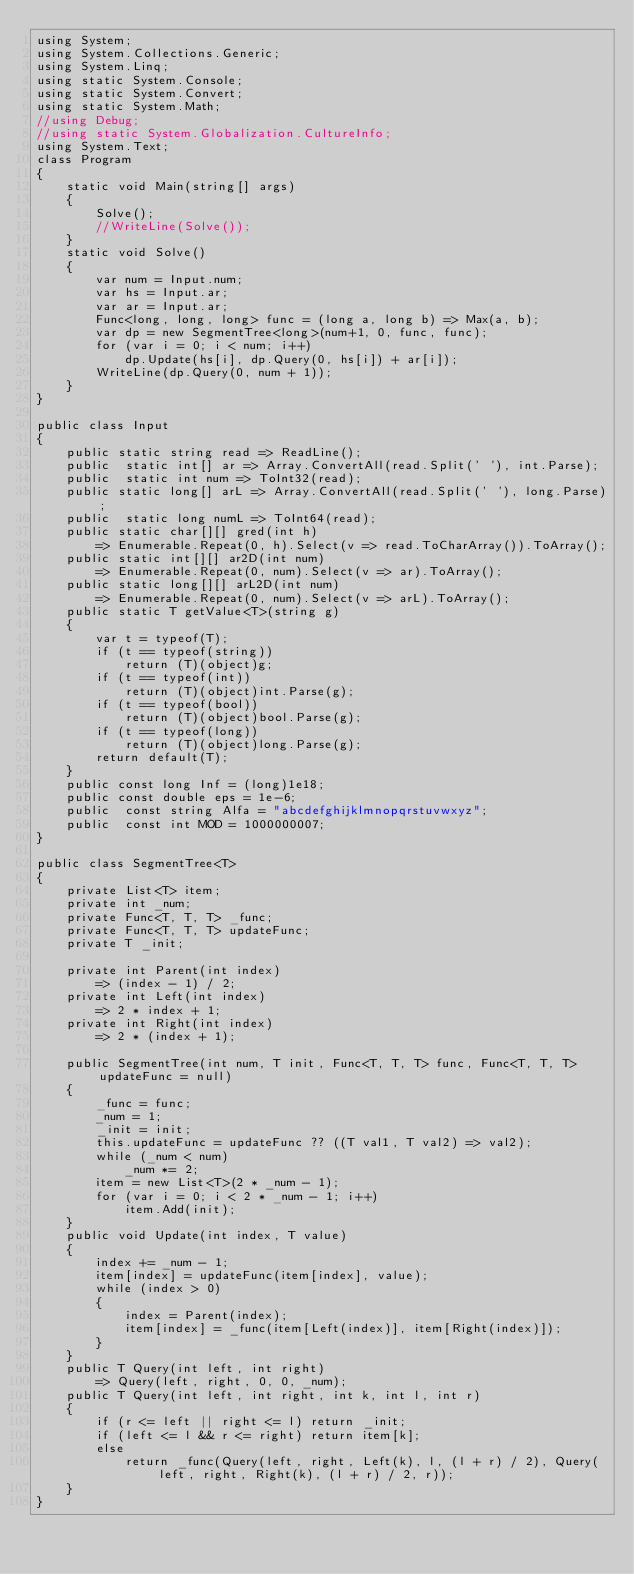Convert code to text. <code><loc_0><loc_0><loc_500><loc_500><_C#_>using System;
using System.Collections.Generic;
using System.Linq;
using static System.Console;
using static System.Convert;
using static System.Math;
//using Debug;
//using static System.Globalization.CultureInfo;
using System.Text;
class Program
{
    static void Main(string[] args)
    {
        Solve();
        //WriteLine(Solve());
    }
    static void Solve()
    {
        var num = Input.num;
        var hs = Input.ar;
        var ar = Input.ar;
        Func<long, long, long> func = (long a, long b) => Max(a, b);
        var dp = new SegmentTree<long>(num+1, 0, func, func);
        for (var i = 0; i < num; i++)
            dp.Update(hs[i], dp.Query(0, hs[i]) + ar[i]);
        WriteLine(dp.Query(0, num + 1));
    }
}

public class Input
{
    public static string read => ReadLine();
    public  static int[] ar => Array.ConvertAll(read.Split(' '), int.Parse);
    public  static int num => ToInt32(read);
    public static long[] arL => Array.ConvertAll(read.Split(' '), long.Parse);
    public  static long numL => ToInt64(read);
    public static char[][] gred(int h) 
        => Enumerable.Repeat(0, h).Select(v => read.ToCharArray()).ToArray();
    public static int[][] ar2D(int num)
        => Enumerable.Repeat(0, num).Select(v => ar).ToArray();
    public static long[][] arL2D(int num)
        => Enumerable.Repeat(0, num).Select(v => arL).ToArray();
    public static T getValue<T>(string g)
    {
        var t = typeof(T);
        if (t == typeof(string))
            return (T)(object)g;
        if (t == typeof(int))
            return (T)(object)int.Parse(g);
        if (t == typeof(bool))
            return (T)(object)bool.Parse(g);
        if (t == typeof(long))
            return (T)(object)long.Parse(g);
        return default(T);
    }
    public const long Inf = (long)1e18;
    public const double eps = 1e-6;
    public  const string Alfa = "abcdefghijklmnopqrstuvwxyz";
    public  const int MOD = 1000000007;
}

public class SegmentTree<T>
{
    private List<T> item;
    private int _num;
    private Func<T, T, T> _func;
    private Func<T, T, T> updateFunc;
    private T _init;

    private int Parent(int index)
        => (index - 1) / 2;
    private int Left(int index)
        => 2 * index + 1;
    private int Right(int index)
        => 2 * (index + 1);

    public SegmentTree(int num, T init, Func<T, T, T> func, Func<T, T, T> updateFunc = null)
    {
        _func = func;
        _num = 1;
        _init = init;
        this.updateFunc = updateFunc ?? ((T val1, T val2) => val2);
        while (_num < num)
            _num *= 2;
        item = new List<T>(2 * _num - 1);
        for (var i = 0; i < 2 * _num - 1; i++)
            item.Add(init);
    }
    public void Update(int index, T value)
    {
        index += _num - 1;
        item[index] = updateFunc(item[index], value);
        while (index > 0)
        {
            index = Parent(index);
            item[index] = _func(item[Left(index)], item[Right(index)]);
        }
    }
    public T Query(int left, int right)
        => Query(left, right, 0, 0, _num);
    public T Query(int left, int right, int k, int l, int r)
    {
        if (r <= left || right <= l) return _init;
        if (left <= l && r <= right) return item[k];
        else
            return _func(Query(left, right, Left(k), l, (l + r) / 2), Query(left, right, Right(k), (l + r) / 2, r));
    }
}
</code> 